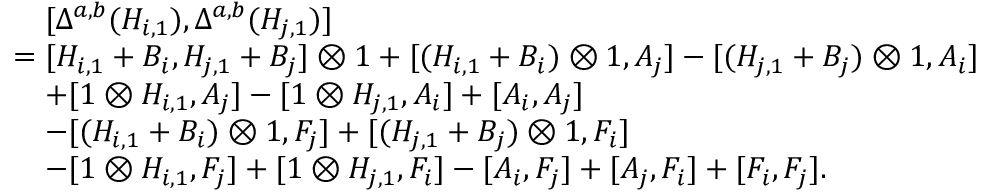<formula> <loc_0><loc_0><loc_500><loc_500>\begin{array} { r l } & { \quad [ \Delta ^ { a , b } ( H _ { i , 1 } ) , \Delta ^ { a , b } ( H _ { j , 1 } ) ] } \\ & { = [ H _ { i , 1 } + B _ { i } , H _ { j , 1 } + B _ { j } ] \otimes 1 + [ ( H _ { i , 1 } + B _ { i } ) \otimes 1 , A _ { j } ] - [ ( H _ { j , 1 } + B _ { j } ) \otimes 1 , A _ { i } ] } \\ & { \quad + [ 1 \otimes H _ { i , 1 } , A _ { j } ] - [ 1 \otimes H _ { j , 1 } , A _ { i } ] + [ A _ { i } , A _ { j } ] } \\ & { \quad - [ ( H _ { i , 1 } + B _ { i } ) \otimes 1 , F _ { j } ] + [ ( H _ { j , 1 } + B _ { j } ) \otimes 1 , F _ { i } ] } \\ & { \quad - [ 1 \otimes H _ { i , 1 } , F _ { j } ] + [ 1 \otimes H _ { j , 1 } , F _ { i } ] - [ A _ { i } , F _ { j } ] + [ A _ { j } , F _ { i } ] + [ F _ { i } , F _ { j } ] . } \end{array}</formula> 